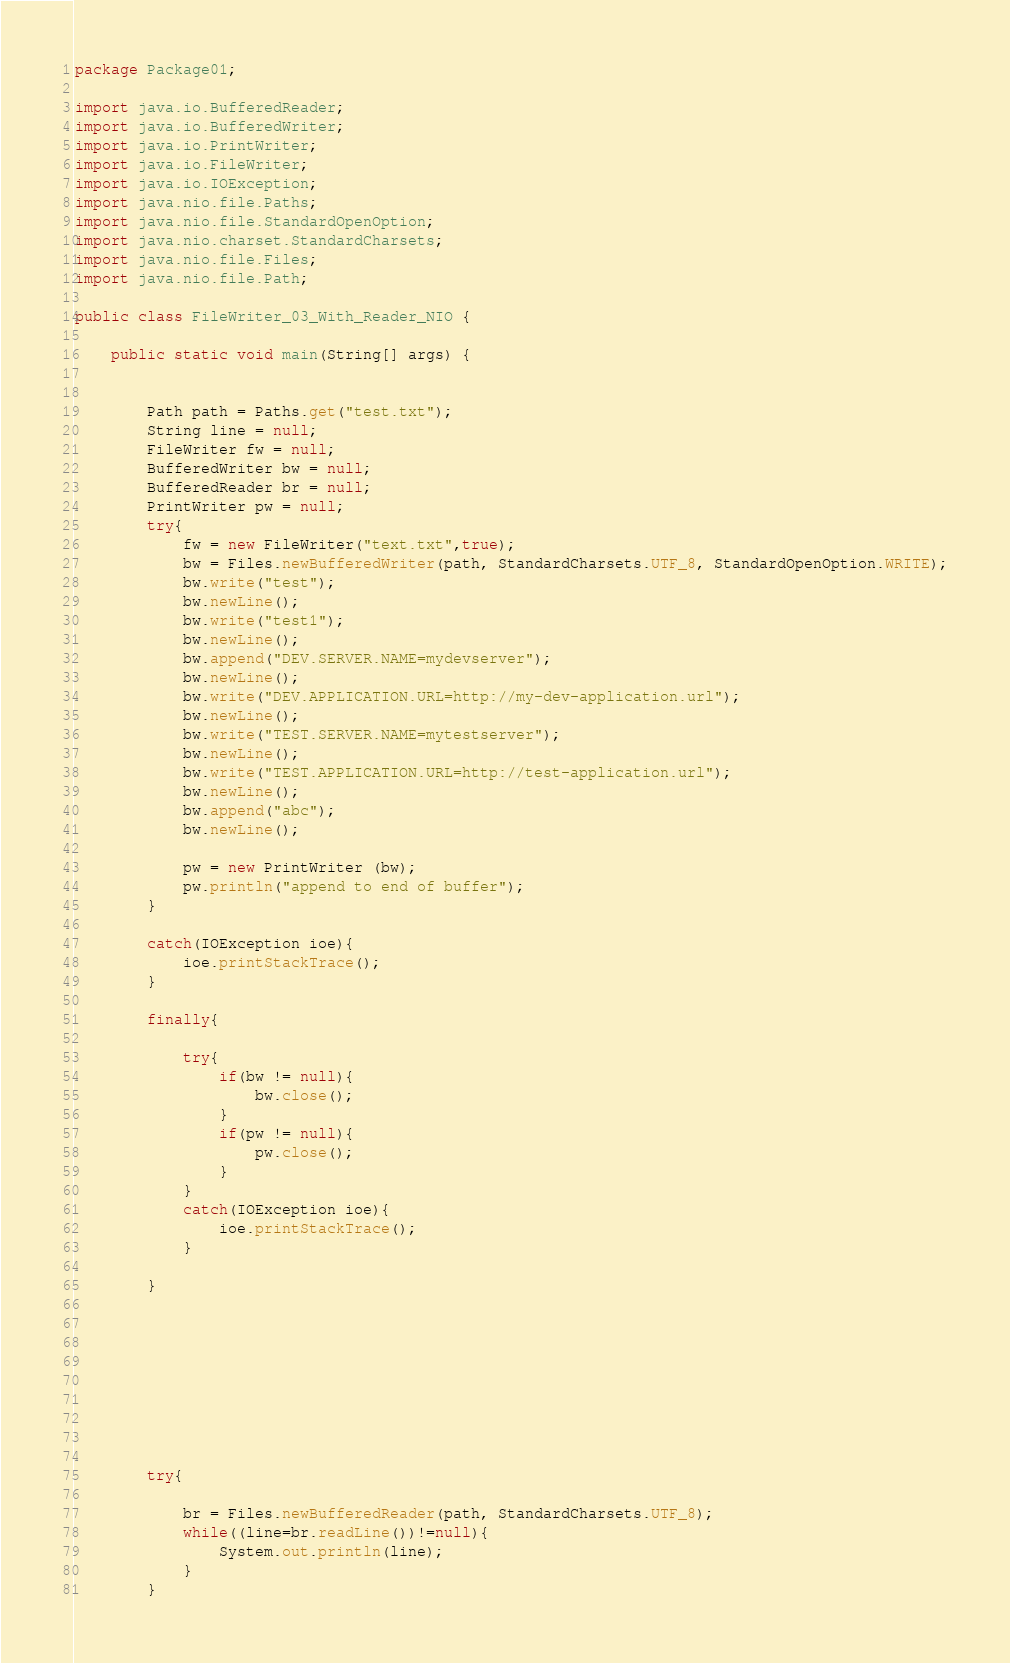<code> <loc_0><loc_0><loc_500><loc_500><_Java_>package Package01;

import java.io.BufferedReader;
import java.io.BufferedWriter;
import java.io.PrintWriter;
import java.io.FileWriter;
import java.io.IOException;
import java.nio.file.Paths;
import java.nio.file.StandardOpenOption;
import java.nio.charset.StandardCharsets;
import java.nio.file.Files;
import java.nio.file.Path;

public class FileWriter_03_With_Reader_NIO {

	public static void main(String[] args) {
		
	
		Path path = Paths.get("test.txt");
		String line = null;
		FileWriter fw = null;
		BufferedWriter bw = null;
		BufferedReader br = null;
		PrintWriter pw = null;
		try{
			fw = new FileWriter("text.txt",true);
			bw = Files.newBufferedWriter(path, StandardCharsets.UTF_8, StandardOpenOption.WRITE);
			bw.write("test");
			bw.newLine();
			bw.write("test1");
			bw.newLine();
			bw.append("DEV.SERVER.NAME=mydevserver");
			bw.newLine();
			bw.write("DEV.APPLICATION.URL=http://my-dev-application.url");
			bw.newLine();
			bw.write("TEST.SERVER.NAME=mytestserver");
			bw.newLine();
			bw.write("TEST.APPLICATION.URL=http://test-application.url");
			bw.newLine();
			bw.append("abc");
			bw.newLine();
			
			pw = new PrintWriter (bw);
			pw.println("append to end of buffer");
		}
		
		catch(IOException ioe){
			ioe.printStackTrace();
		}
		
		finally{
			
			try{
				if(bw != null){
					bw.close();
				}
				if(pw != null){
					pw.close();
				}
			}
			catch(IOException ioe){
				ioe.printStackTrace();
			}
		
		}
		
		
		
		

		
		
		
		
		try{

			br = Files.newBufferedReader(path, StandardCharsets.UTF_8);
			while((line=br.readLine())!=null){
				System.out.println(line);
			}
		}</code> 